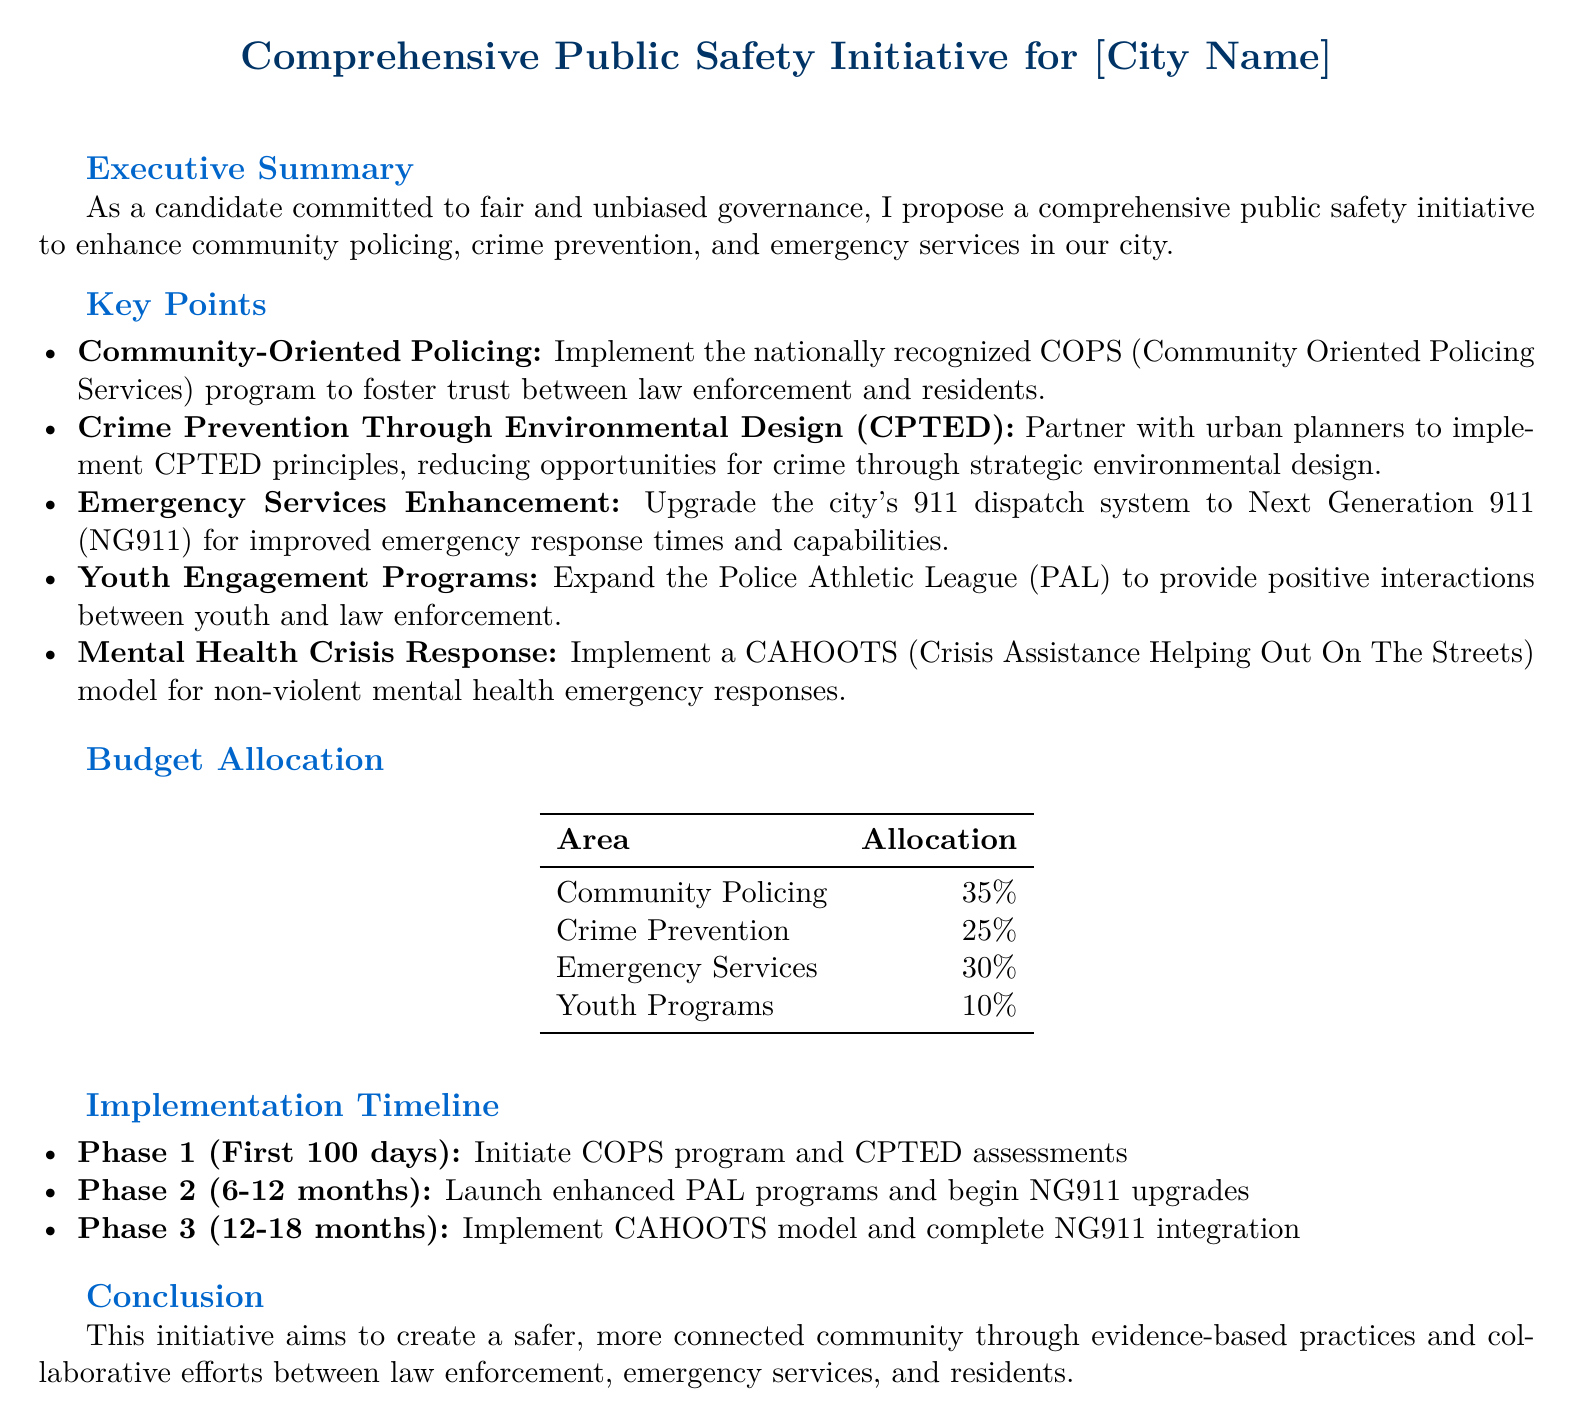What is the title of the initiative? The title of the initiative is mentioned in the header of the document.
Answer: Comprehensive Public Safety Initiative for [City Name] What percentage of the budget is allocated to Community Policing? The budget allocation is detailed in the table under the Budget Allocation section.
Answer: 35% What does the COPS program stand for? The acronym COPS is defined in the Key Points section of the document.
Answer: Community Oriented Policing Services What is the implementation timeline for Phase 1? The timeline for Phase 1 is specified in the Implementation Timeline section.
Answer: First 100 days What percentage of the budget is directed towards Youth Programs? This information is found in the Budget Allocation table.
Answer: 10% What is the strategy employed for non-violent mental health emergencies? The strategy is described in the Key Points section regarding mental health crisis response.
Answer: CAHOOTS How many phases are there in the implementation timeline? The number of phases is counted from the Implementation Timeline section.
Answer: 3 What is the main goal of this public safety initiative? The main goal is outlined in the conclusion of the document.
Answer: Create a safer, more connected community 